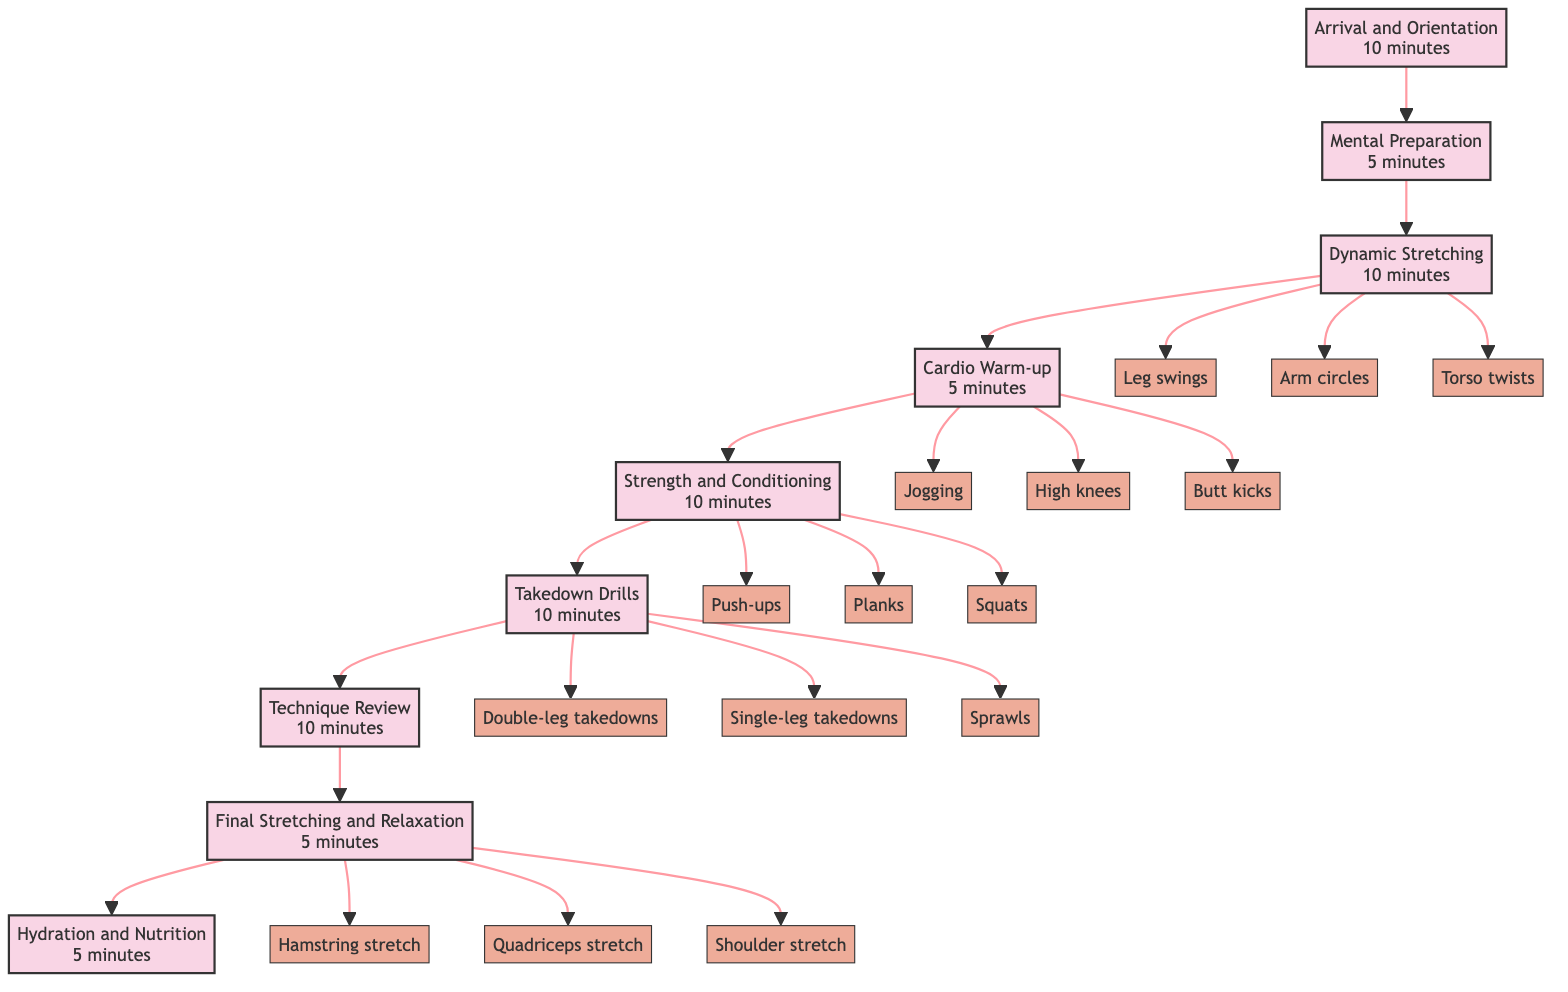What is the first step in the warm-up routine? The diagram indicates that the first step in the warm-up routine is "Arrival and Orientation," which begins the sequence of warm-up activities.
Answer: Arrival and Orientation How long is allocated for Takedown Drills? In the diagram, the time allocation specified for Takedown Drills is 10 minutes.
Answer: 10 minutes What follows Mental Preparation in the routine? The flow chart shows that after Mental Preparation, the next step is "Dynamic Stretching."
Answer: Dynamic Stretching How many substeps are listed under Strength and Conditioning? Upon reviewing the diagram, there are three substeps listed under Strength and Conditioning: Push-ups, Planks, and Squats.
Answer: 3 Which step comes just before Final Stretching and Relaxation? By tracing the flow of the diagram, the step that comes just before Final Stretching and Relaxation is "Technique Review."
Answer: Technique Review What is the total time allocated for the entire warm-up routine? By adding the time allocations for each step (10 + 5 + 10 + 5 + 10 + 10 + 10 + 5 + 5), the total time comes to 70 minutes.
Answer: 70 minutes Name two activities listed under Dynamic Stretching. The diagram indicates that two of the activities under Dynamic Stretching are "Leg swings" and "Arm circles."
Answer: Leg swings, Arm circles What type of exercise is emphasized during the Cardio Warm-up? The diagram specifies that the exercises emphasized during the Cardio Warm-up are light cardiovascular exercises, such as jogging, high knees, and butt kicks.
Answer: Cardio exercises Which step includes hydration activities? According to the diagram, the step that includes hydration activities is "Hydration and Nutrition."
Answer: Hydration and Nutrition 